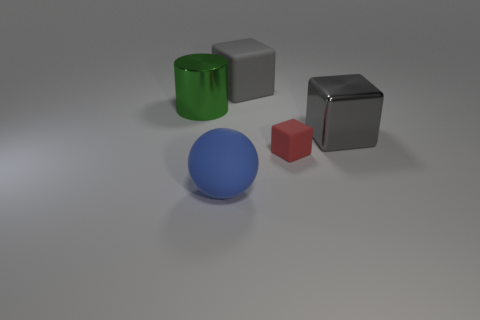Add 1 small green metal things. How many objects exist? 6 Subtract all cylinders. How many objects are left? 4 Subtract all tiny shiny cylinders. Subtract all red things. How many objects are left? 4 Add 5 gray matte things. How many gray matte things are left? 6 Add 2 large gray shiny objects. How many large gray shiny objects exist? 3 Subtract 0 yellow cylinders. How many objects are left? 5 